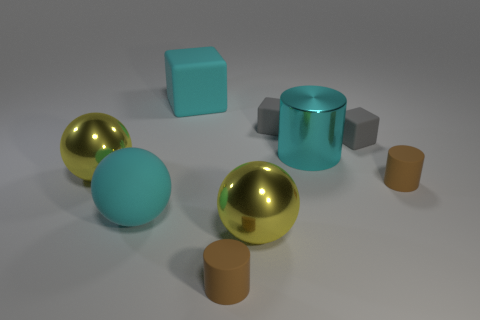Add 1 small brown rubber objects. How many objects exist? 10 Subtract all cylinders. How many objects are left? 6 Subtract all big cyan balls. Subtract all big metal objects. How many objects are left? 5 Add 8 big cyan matte spheres. How many big cyan matte spheres are left? 9 Add 6 brown rubber cylinders. How many brown rubber cylinders exist? 8 Subtract 0 yellow cubes. How many objects are left? 9 